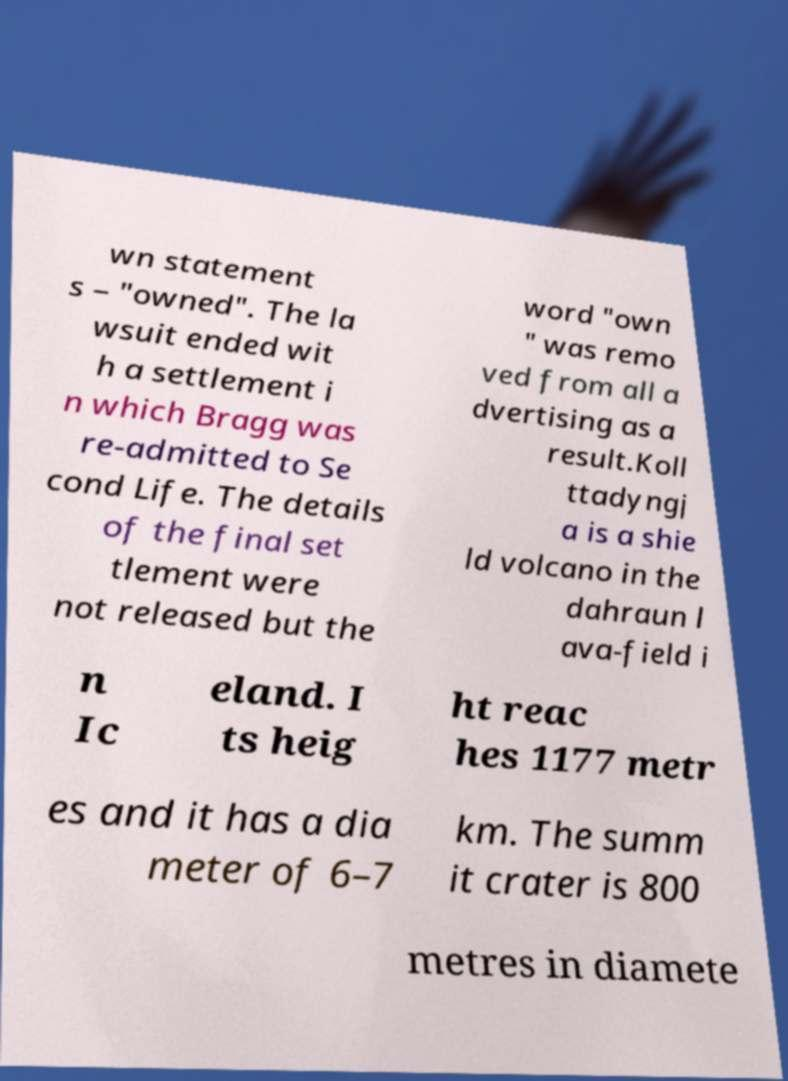What messages or text are displayed in this image? I need them in a readable, typed format. wn statement s – "owned". The la wsuit ended wit h a settlement i n which Bragg was re-admitted to Se cond Life. The details of the final set tlement were not released but the word "own " was remo ved from all a dvertising as a result.Koll ttadyngj a is a shie ld volcano in the dahraun l ava-field i n Ic eland. I ts heig ht reac hes 1177 metr es and it has a dia meter of 6–7 km. The summ it crater is 800 metres in diamete 